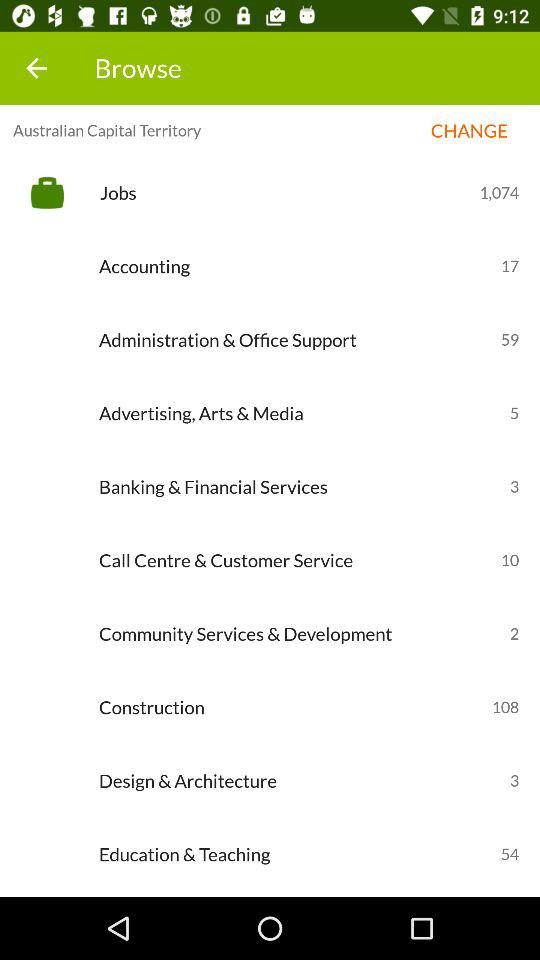How many jobs are in the construction department? There are 108 jobs in the construction department. 